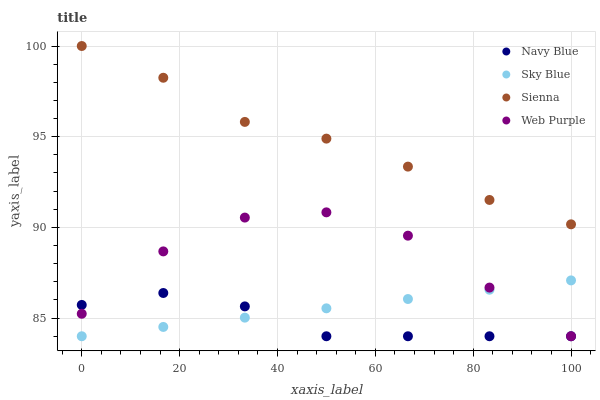Does Navy Blue have the minimum area under the curve?
Answer yes or no. Yes. Does Sienna have the maximum area under the curve?
Answer yes or no. Yes. Does Web Purple have the minimum area under the curve?
Answer yes or no. No. Does Web Purple have the maximum area under the curve?
Answer yes or no. No. Is Sky Blue the smoothest?
Answer yes or no. Yes. Is Web Purple the roughest?
Answer yes or no. Yes. Is Navy Blue the smoothest?
Answer yes or no. No. Is Navy Blue the roughest?
Answer yes or no. No. Does Navy Blue have the lowest value?
Answer yes or no. Yes. Does Sienna have the highest value?
Answer yes or no. Yes. Does Web Purple have the highest value?
Answer yes or no. No. Is Sky Blue less than Sienna?
Answer yes or no. Yes. Is Sienna greater than Navy Blue?
Answer yes or no. Yes. Does Navy Blue intersect Sky Blue?
Answer yes or no. Yes. Is Navy Blue less than Sky Blue?
Answer yes or no. No. Is Navy Blue greater than Sky Blue?
Answer yes or no. No. Does Sky Blue intersect Sienna?
Answer yes or no. No. 